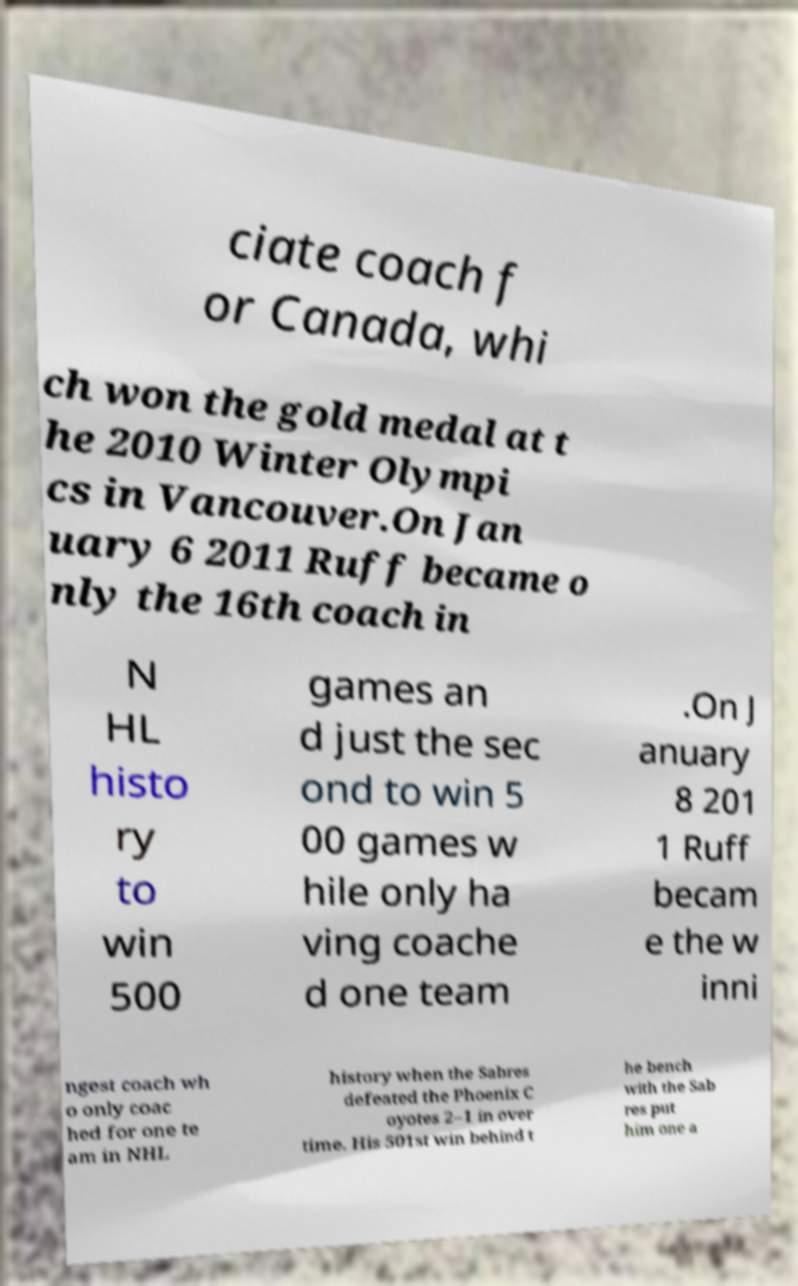Could you assist in decoding the text presented in this image and type it out clearly? ciate coach f or Canada, whi ch won the gold medal at t he 2010 Winter Olympi cs in Vancouver.On Jan uary 6 2011 Ruff became o nly the 16th coach in N HL histo ry to win 500 games an d just the sec ond to win 5 00 games w hile only ha ving coache d one team .On J anuary 8 201 1 Ruff becam e the w inni ngest coach wh o only coac hed for one te am in NHL history when the Sabres defeated the Phoenix C oyotes 2–1 in over time. His 501st win behind t he bench with the Sab res put him one a 